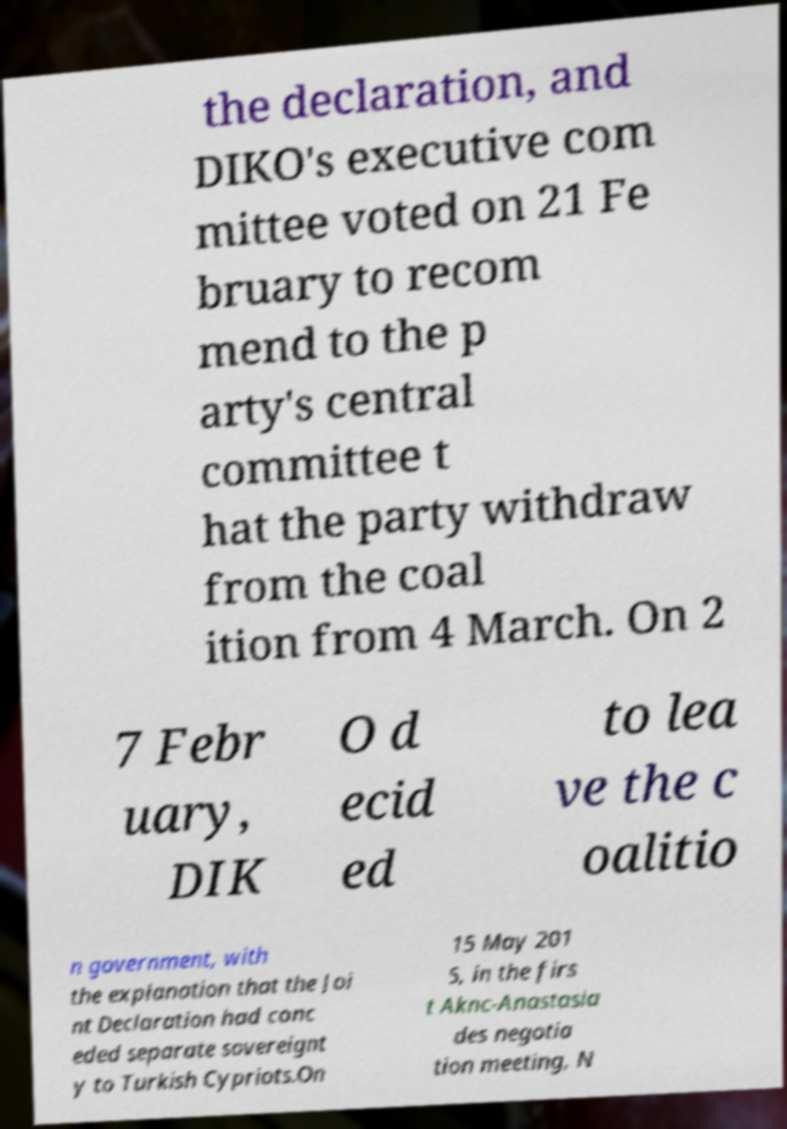Can you accurately transcribe the text from the provided image for me? the declaration, and DIKO's executive com mittee voted on 21 Fe bruary to recom mend to the p arty's central committee t hat the party withdraw from the coal ition from 4 March. On 2 7 Febr uary, DIK O d ecid ed to lea ve the c oalitio n government, with the explanation that the Joi nt Declaration had conc eded separate sovereignt y to Turkish Cypriots.On 15 May 201 5, in the firs t Aknc-Anastasia des negotia tion meeting, N 